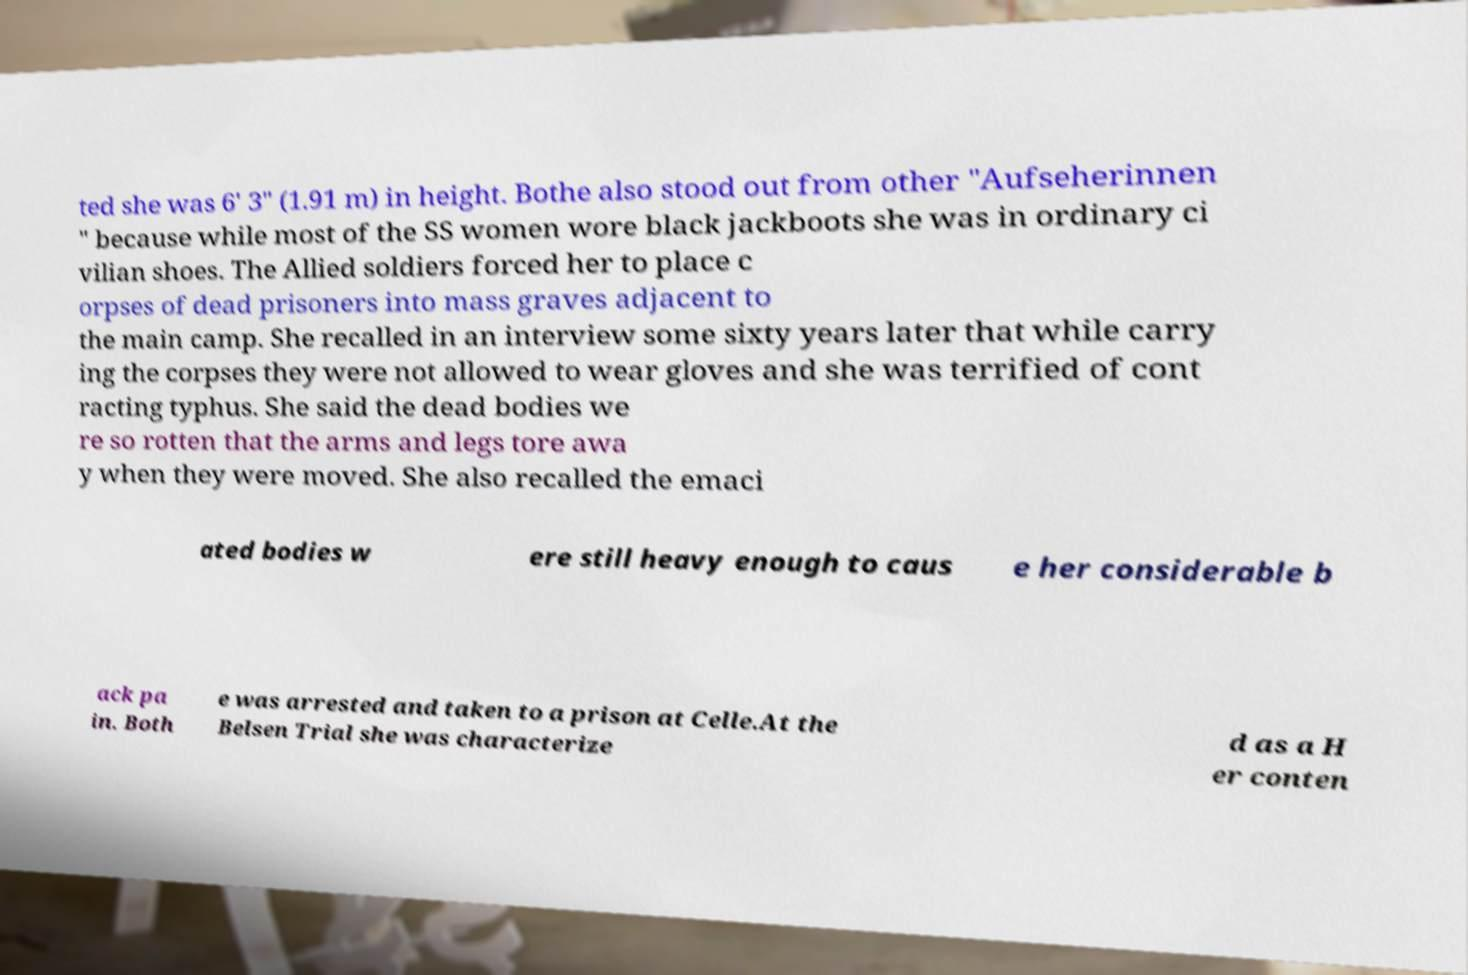What messages or text are displayed in this image? I need them in a readable, typed format. ted she was 6' 3" (1.91 m) in height. Bothe also stood out from other "Aufseherinnen " because while most of the SS women wore black jackboots she was in ordinary ci vilian shoes. The Allied soldiers forced her to place c orpses of dead prisoners into mass graves adjacent to the main camp. She recalled in an interview some sixty years later that while carry ing the corpses they were not allowed to wear gloves and she was terrified of cont racting typhus. She said the dead bodies we re so rotten that the arms and legs tore awa y when they were moved. She also recalled the emaci ated bodies w ere still heavy enough to caus e her considerable b ack pa in. Both e was arrested and taken to a prison at Celle.At the Belsen Trial she was characterize d as a H er conten 